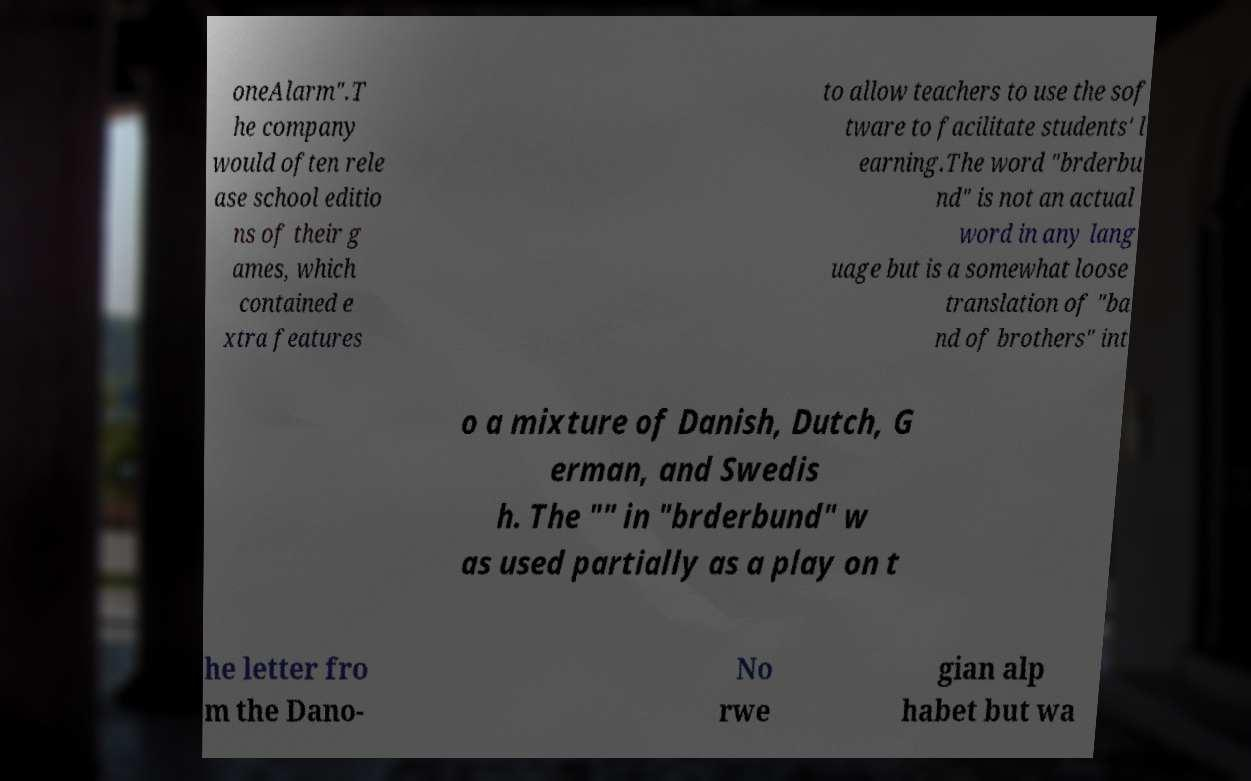Please read and relay the text visible in this image. What does it say? oneAlarm".T he company would often rele ase school editio ns of their g ames, which contained e xtra features to allow teachers to use the sof tware to facilitate students' l earning.The word "brderbu nd" is not an actual word in any lang uage but is a somewhat loose translation of "ba nd of brothers" int o a mixture of Danish, Dutch, G erman, and Swedis h. The "" in "brderbund" w as used partially as a play on t he letter fro m the Dano- No rwe gian alp habet but wa 